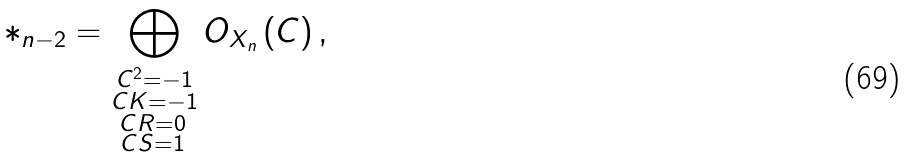Convert formula to latex. <formula><loc_0><loc_0><loc_500><loc_500>\mathcal { \Lambda } _ { n - 2 } = \bigoplus _ { \substack { C ^ { 2 } = - 1 \\ C K = - 1 \\ C R = 0 \, \\ C S = 1 \, } } O _ { X _ { n } } \left ( C \right ) ,</formula> 